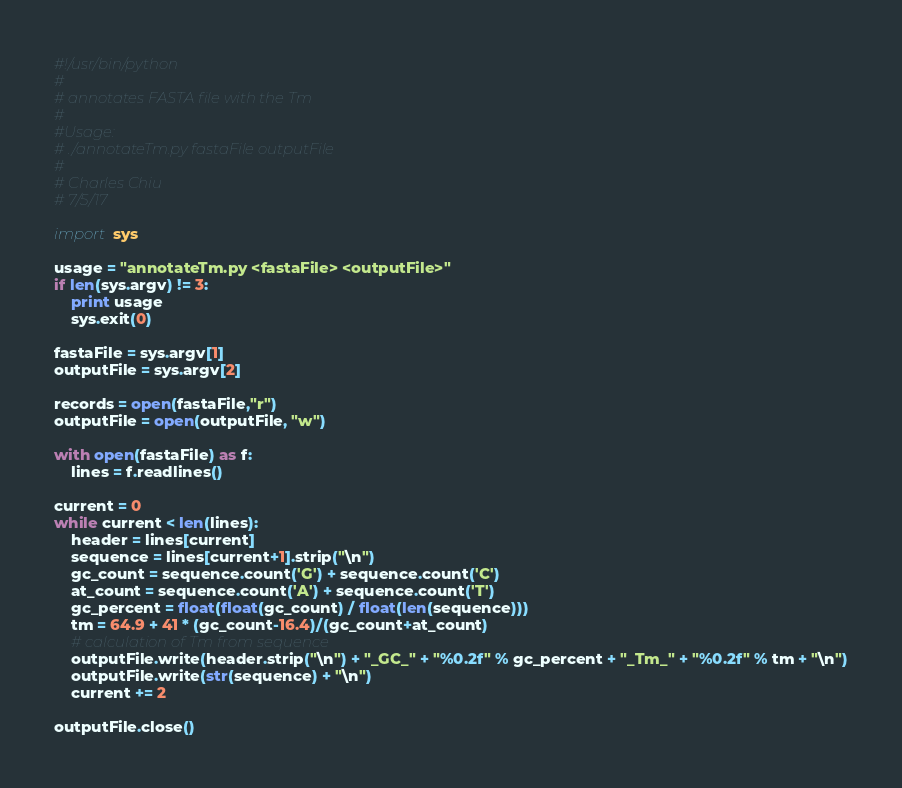<code> <loc_0><loc_0><loc_500><loc_500><_Python_>#!/usr/bin/python
#
# annotates FASTA file with the Tm
#
#Usage:
# ./annotateTm.py fastaFile outputFile
#
# Charles Chiu
# 7/5/17

import sys

usage = "annotateTm.py <fastaFile> <outputFile>"
if len(sys.argv) != 3:
    print usage
    sys.exit(0)

fastaFile = sys.argv[1]
outputFile = sys.argv[2]

records = open(fastaFile,"r")
outputFile = open(outputFile, "w")

with open(fastaFile) as f:
    lines = f.readlines()
    
current = 0
while current < len(lines):
    header = lines[current]
    sequence = lines[current+1].strip("\n")
    gc_count = sequence.count('G') + sequence.count('C')
    at_count = sequence.count('A') + sequence.count('T')
    gc_percent = float(float(gc_count) / float(len(sequence)))
    tm = 64.9 + 41 * (gc_count-16.4)/(gc_count+at_count)
    # calculation of Tm from sequence
    outputFile.write(header.strip("\n") + "_GC_" + "%0.2f" % gc_percent + "_Tm_" + "%0.2f" % tm + "\n")
    outputFile.write(str(sequence) + "\n")
    current += 2

outputFile.close()
</code> 